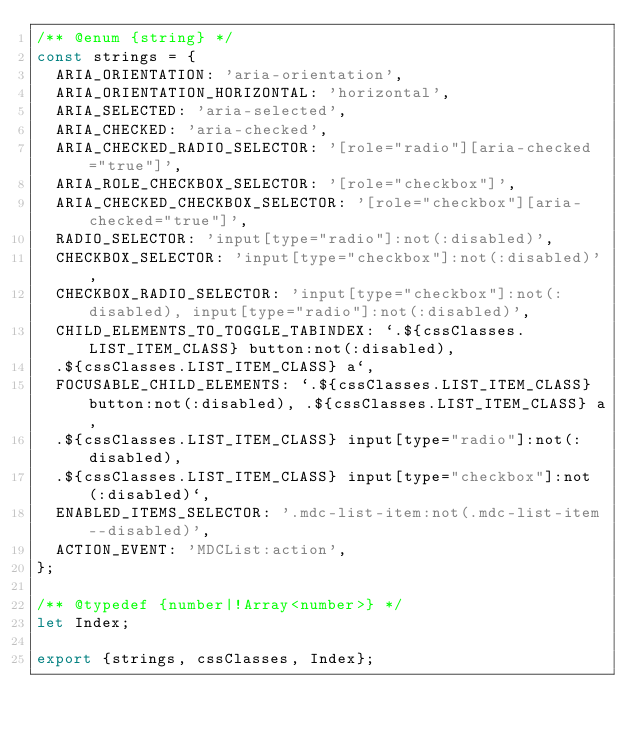Convert code to text. <code><loc_0><loc_0><loc_500><loc_500><_JavaScript_>/** @enum {string} */
const strings = {
  ARIA_ORIENTATION: 'aria-orientation',
  ARIA_ORIENTATION_HORIZONTAL: 'horizontal',
  ARIA_SELECTED: 'aria-selected',
  ARIA_CHECKED: 'aria-checked',
  ARIA_CHECKED_RADIO_SELECTOR: '[role="radio"][aria-checked="true"]',
  ARIA_ROLE_CHECKBOX_SELECTOR: '[role="checkbox"]',
  ARIA_CHECKED_CHECKBOX_SELECTOR: '[role="checkbox"][aria-checked="true"]',
  RADIO_SELECTOR: 'input[type="radio"]:not(:disabled)',
  CHECKBOX_SELECTOR: 'input[type="checkbox"]:not(:disabled)',
  CHECKBOX_RADIO_SELECTOR: 'input[type="checkbox"]:not(:disabled), input[type="radio"]:not(:disabled)',
  CHILD_ELEMENTS_TO_TOGGLE_TABINDEX: `.${cssClasses.LIST_ITEM_CLASS} button:not(:disabled),
  .${cssClasses.LIST_ITEM_CLASS} a`,
  FOCUSABLE_CHILD_ELEMENTS: `.${cssClasses.LIST_ITEM_CLASS} button:not(:disabled), .${cssClasses.LIST_ITEM_CLASS} a,
  .${cssClasses.LIST_ITEM_CLASS} input[type="radio"]:not(:disabled),
  .${cssClasses.LIST_ITEM_CLASS} input[type="checkbox"]:not(:disabled)`,
  ENABLED_ITEMS_SELECTOR: '.mdc-list-item:not(.mdc-list-item--disabled)',
  ACTION_EVENT: 'MDCList:action',
};

/** @typedef {number|!Array<number>} */
let Index;

export {strings, cssClasses, Index};
</code> 